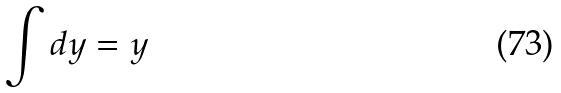<formula> <loc_0><loc_0><loc_500><loc_500>\int d y = y</formula> 